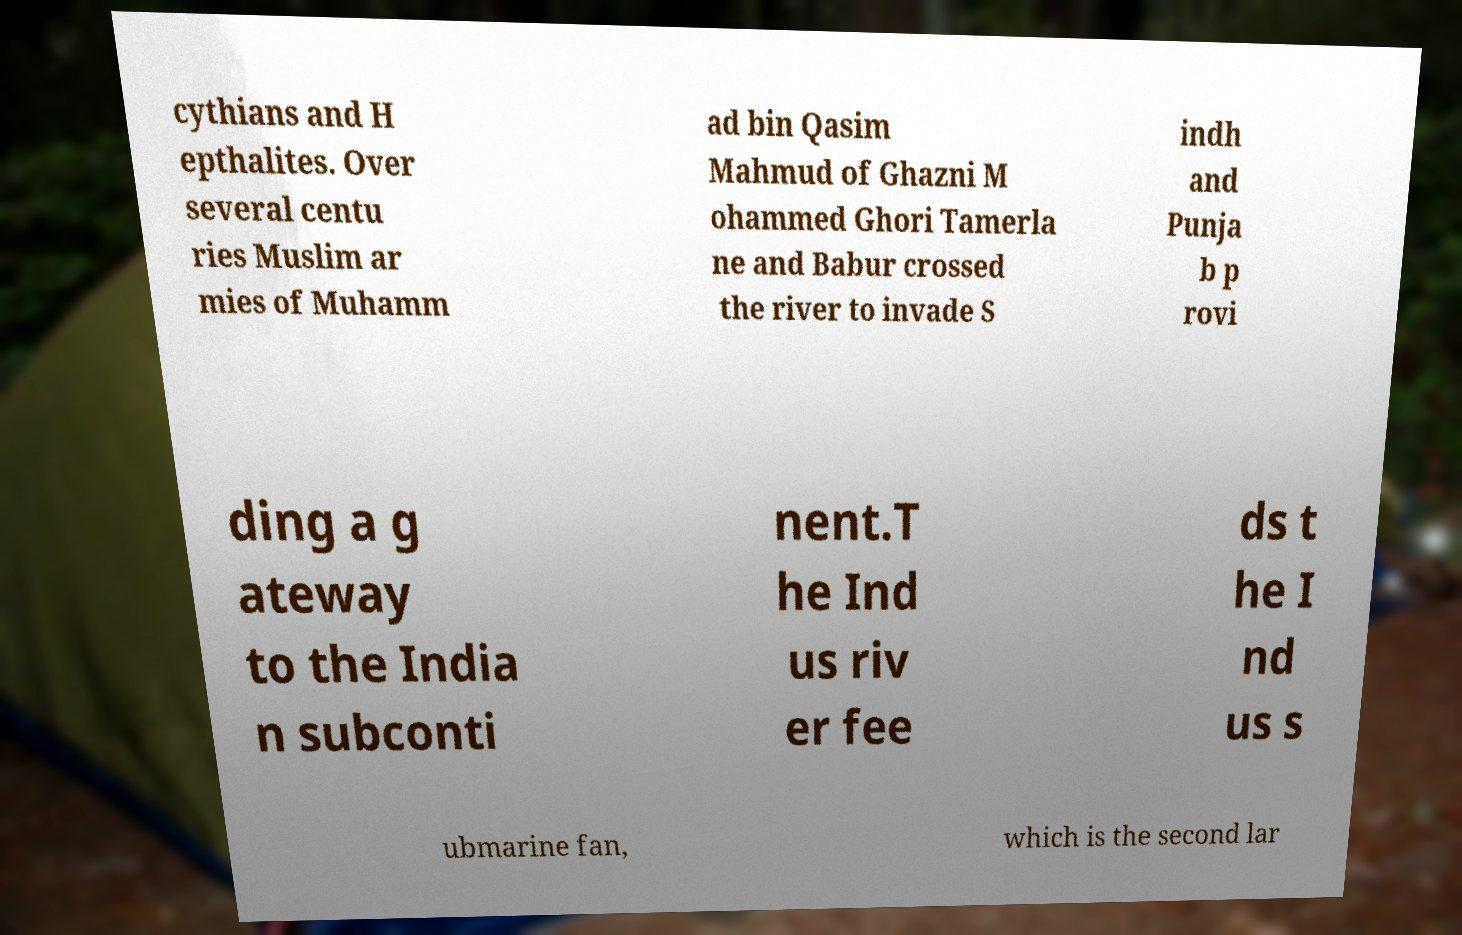Could you extract and type out the text from this image? cythians and H epthalites. Over several centu ries Muslim ar mies of Muhamm ad bin Qasim Mahmud of Ghazni M ohammed Ghori Tamerla ne and Babur crossed the river to invade S indh and Punja b p rovi ding a g ateway to the India n subconti nent.T he Ind us riv er fee ds t he I nd us s ubmarine fan, which is the second lar 